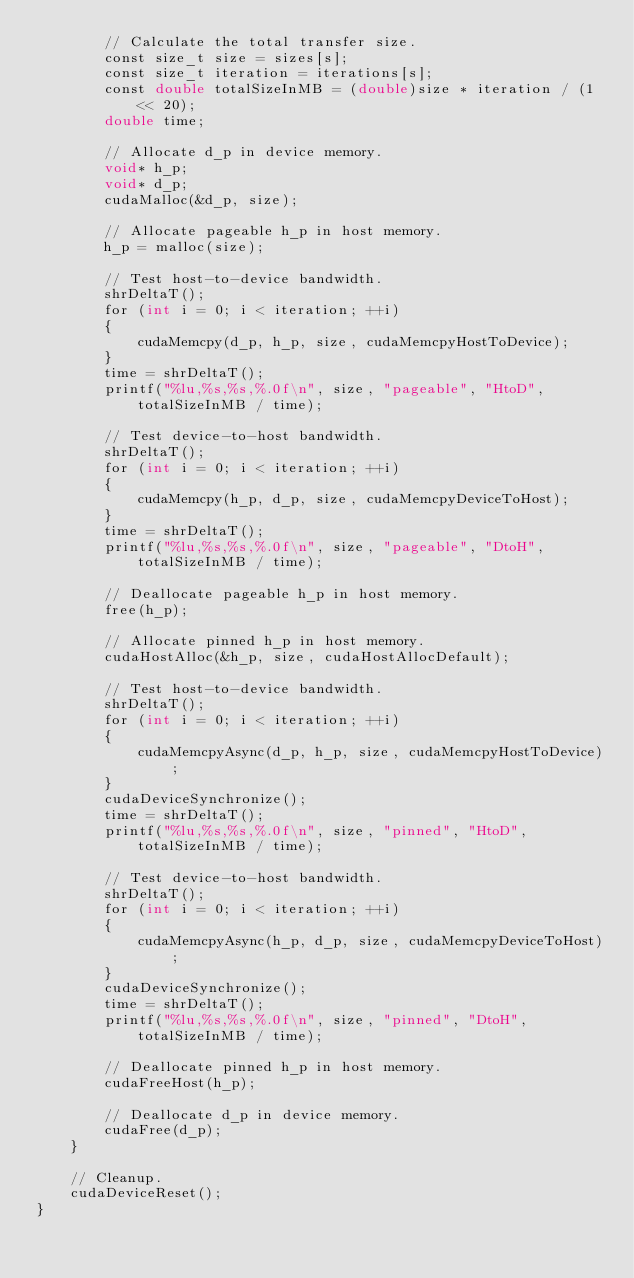Convert code to text. <code><loc_0><loc_0><loc_500><loc_500><_Cuda_>		// Calculate the total transfer size.
		const size_t size = sizes[s];
		const size_t iteration = iterations[s];
		const double totalSizeInMB = (double)size * iteration / (1 << 20);
		double time;

		// Allocate d_p in device memory.
		void* h_p;
		void* d_p;
		cudaMalloc(&d_p, size);

		// Allocate pageable h_p in host memory.
		h_p = malloc(size);

		// Test host-to-device bandwidth.
		shrDeltaT();
		for (int i = 0; i < iteration; ++i)
		{
			cudaMemcpy(d_p, h_p, size, cudaMemcpyHostToDevice);
		}
		time = shrDeltaT();
		printf("%lu,%s,%s,%.0f\n", size, "pageable", "HtoD", totalSizeInMB / time);

		// Test device-to-host bandwidth.
		shrDeltaT();
		for (int i = 0; i < iteration; ++i)
		{
			cudaMemcpy(h_p, d_p, size, cudaMemcpyDeviceToHost);
		}
		time = shrDeltaT();
		printf("%lu,%s,%s,%.0f\n", size, "pageable", "DtoH", totalSizeInMB / time);

		// Deallocate pageable h_p in host memory.
		free(h_p);

		// Allocate pinned h_p in host memory.
        cudaHostAlloc(&h_p, size, cudaHostAllocDefault);

		// Test host-to-device bandwidth.
		shrDeltaT();
		for (int i = 0; i < iteration; ++i)
		{
			cudaMemcpyAsync(d_p, h_p, size, cudaMemcpyHostToDevice);
		}
		cudaDeviceSynchronize();
		time = shrDeltaT();
		printf("%lu,%s,%s,%.0f\n", size, "pinned", "HtoD", totalSizeInMB / time);

		// Test device-to-host bandwidth.
		shrDeltaT();
		for (int i = 0; i < iteration; ++i)
		{
			cudaMemcpyAsync(h_p, d_p, size, cudaMemcpyDeviceToHost);
		}
		cudaDeviceSynchronize();
		time = shrDeltaT();
		printf("%lu,%s,%s,%.0f\n", size, "pinned", "DtoH", totalSizeInMB / time);

		// Deallocate pinned h_p in host memory.
		cudaFreeHost(h_p);

		// Deallocate d_p in device memory.
		cudaFree(d_p);
	}

	// Cleanup.
	cudaDeviceReset();
}
</code> 